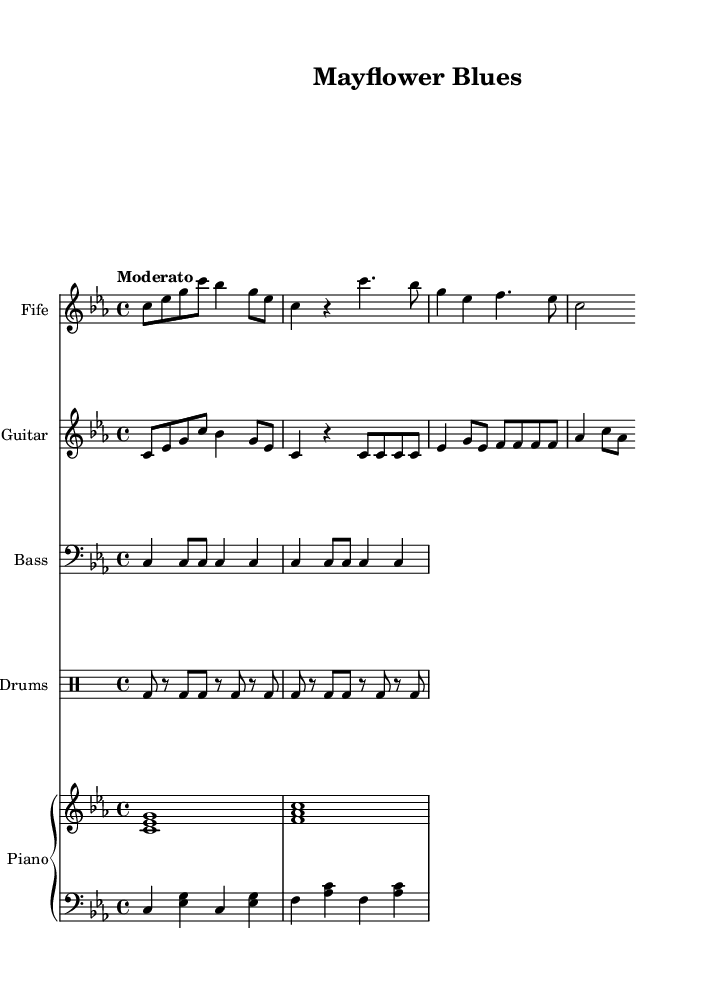What is the key signature of this music? The key signature indicates the key of C minor, which has three flats (B flat, E flat, and A flat). This can be confirmed by looking at the key signature indicated at the beginning of the score.
Answer: C minor What is the tempo marking for this piece? The tempo marking is written as "Moderato," which indicates a moderate pace. This tempo is often used in rhythm and blues music to create a laid-back feel.
Answer: Moderato What is the time signature of the music? The time signature is found at the beginning of the score, listed as 4/4, which is a common time signature in many music genres, including rhythm and blues.
Answer: 4/4 How many measures are present in the chorus? The chorus consists of four measures, as indicated by the four lines of notation under the fife staff, each corresponding to a measure.
Answer: Four Which colonial-era instrument is used for the main melody? The fife is typically a colonial-era instrument and is used for the main melody in this piece as denoted by the staff labeled "Fife."
Answer: Fife What are the two primary chords used in the piano's left hand part? The left hand of the piano plays the chords C and F, which can be seen by examining the notes specified in that staff and identifying the pitch classes.
Answer: C and F 